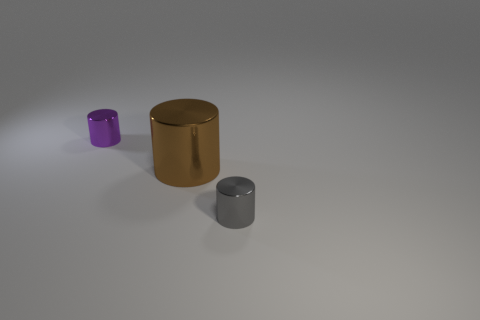Add 1 tiny cylinders. How many objects exist? 4 Add 2 purple metal cylinders. How many purple metal cylinders exist? 3 Subtract 0 yellow blocks. How many objects are left? 3 Subtract all shiny cylinders. Subtract all big matte cylinders. How many objects are left? 0 Add 1 tiny gray shiny cylinders. How many tiny gray shiny cylinders are left? 2 